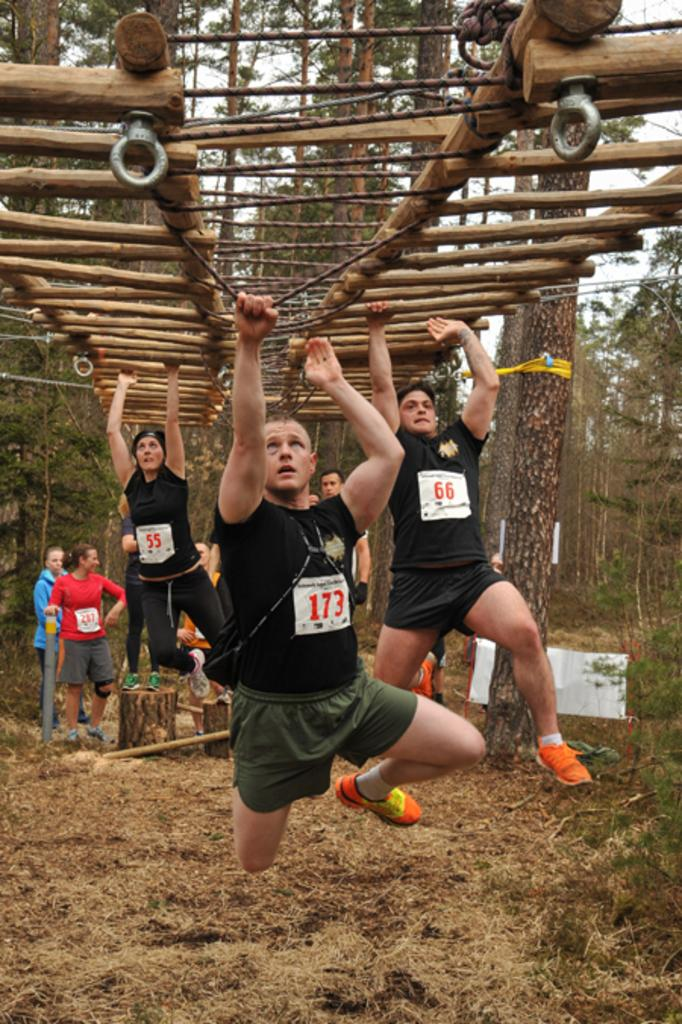<image>
Provide a brief description of the given image. Number 173 appears to be in the lead of this race. 